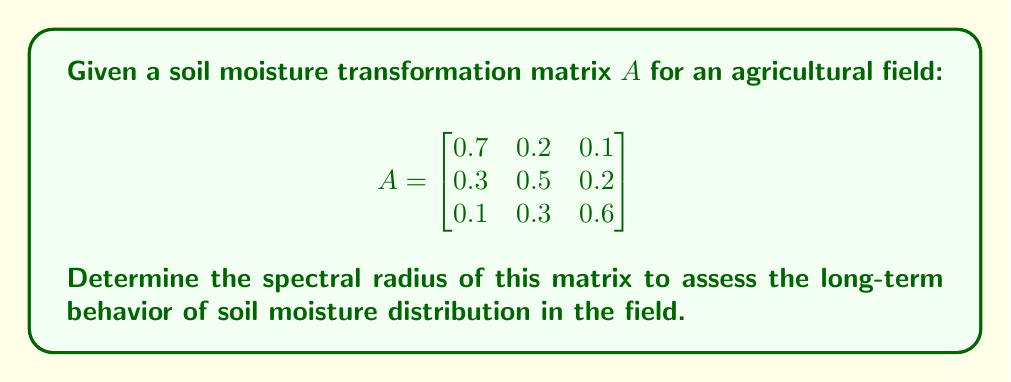Could you help me with this problem? To determine the spectral radius of matrix $A$, we need to follow these steps:

1. Calculate the characteristic polynomial of $A$:
   $det(A - \lambda I) = 0$
   
   $$\begin{vmatrix}
   0.7-\lambda & 0.2 & 0.1 \\
   0.3 & 0.5-\lambda & 0.2 \\
   0.1 & 0.3 & 0.6-\lambda
   \end{vmatrix} = 0$$

2. Expand the determinant:
   $(0.7-\lambda)[(0.5-\lambda)(0.6-\lambda)-0.06] - 0.2[0.3(0.6-\lambda)-0.02] + 0.1[0.3(0.5-\lambda)-0.06] = 0$

3. Simplify:
   $-\lambda^3 + 1.8\lambda^2 - 0.97\lambda + 0.158 = 0$

4. Solve the characteristic equation:
   The roots of this equation are the eigenvalues of $A$. Using a numerical method or computer algebra system, we find:
   $\lambda_1 \approx 1.0000$
   $\lambda_2 \approx 0.4724$
   $\lambda_3 \approx 0.3276$

5. The spectral radius $\rho(A)$ is the maximum absolute value of the eigenvalues:
   $\rho(A) = \max(|\lambda_1|, |\lambda_2|, |\lambda_3|) = |\lambda_1| \approx 1.0000$

The spectral radius being 1 indicates that the soil moisture distribution will reach a steady state in the long term, neither diverging nor converging to zero.
Answer: $\rho(A) = 1$ 